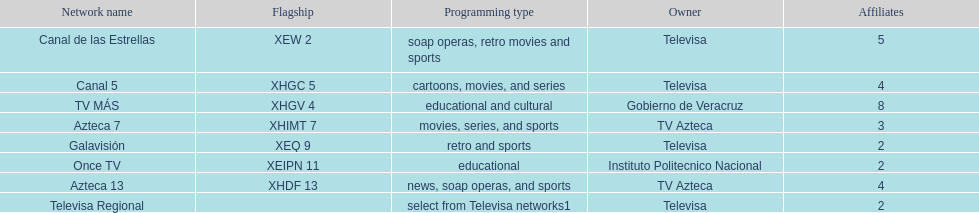What is the number of affiliates of canal de las estrellas. 5. 